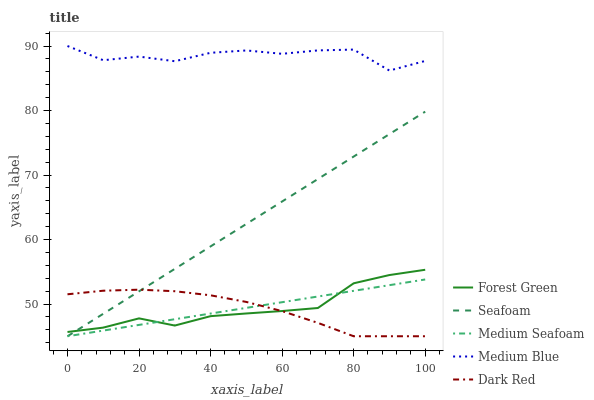Does Dark Red have the minimum area under the curve?
Answer yes or no. Yes. Does Medium Blue have the maximum area under the curve?
Answer yes or no. Yes. Does Forest Green have the minimum area under the curve?
Answer yes or no. No. Does Forest Green have the maximum area under the curve?
Answer yes or no. No. Is Medium Seafoam the smoothest?
Answer yes or no. Yes. Is Medium Blue the roughest?
Answer yes or no. Yes. Is Forest Green the smoothest?
Answer yes or no. No. Is Forest Green the roughest?
Answer yes or no. No. Does Forest Green have the lowest value?
Answer yes or no. No. Does Medium Blue have the highest value?
Answer yes or no. Yes. Does Forest Green have the highest value?
Answer yes or no. No. Is Seafoam less than Medium Blue?
Answer yes or no. Yes. Is Medium Blue greater than Dark Red?
Answer yes or no. Yes. Does Seafoam intersect Medium Blue?
Answer yes or no. No. 